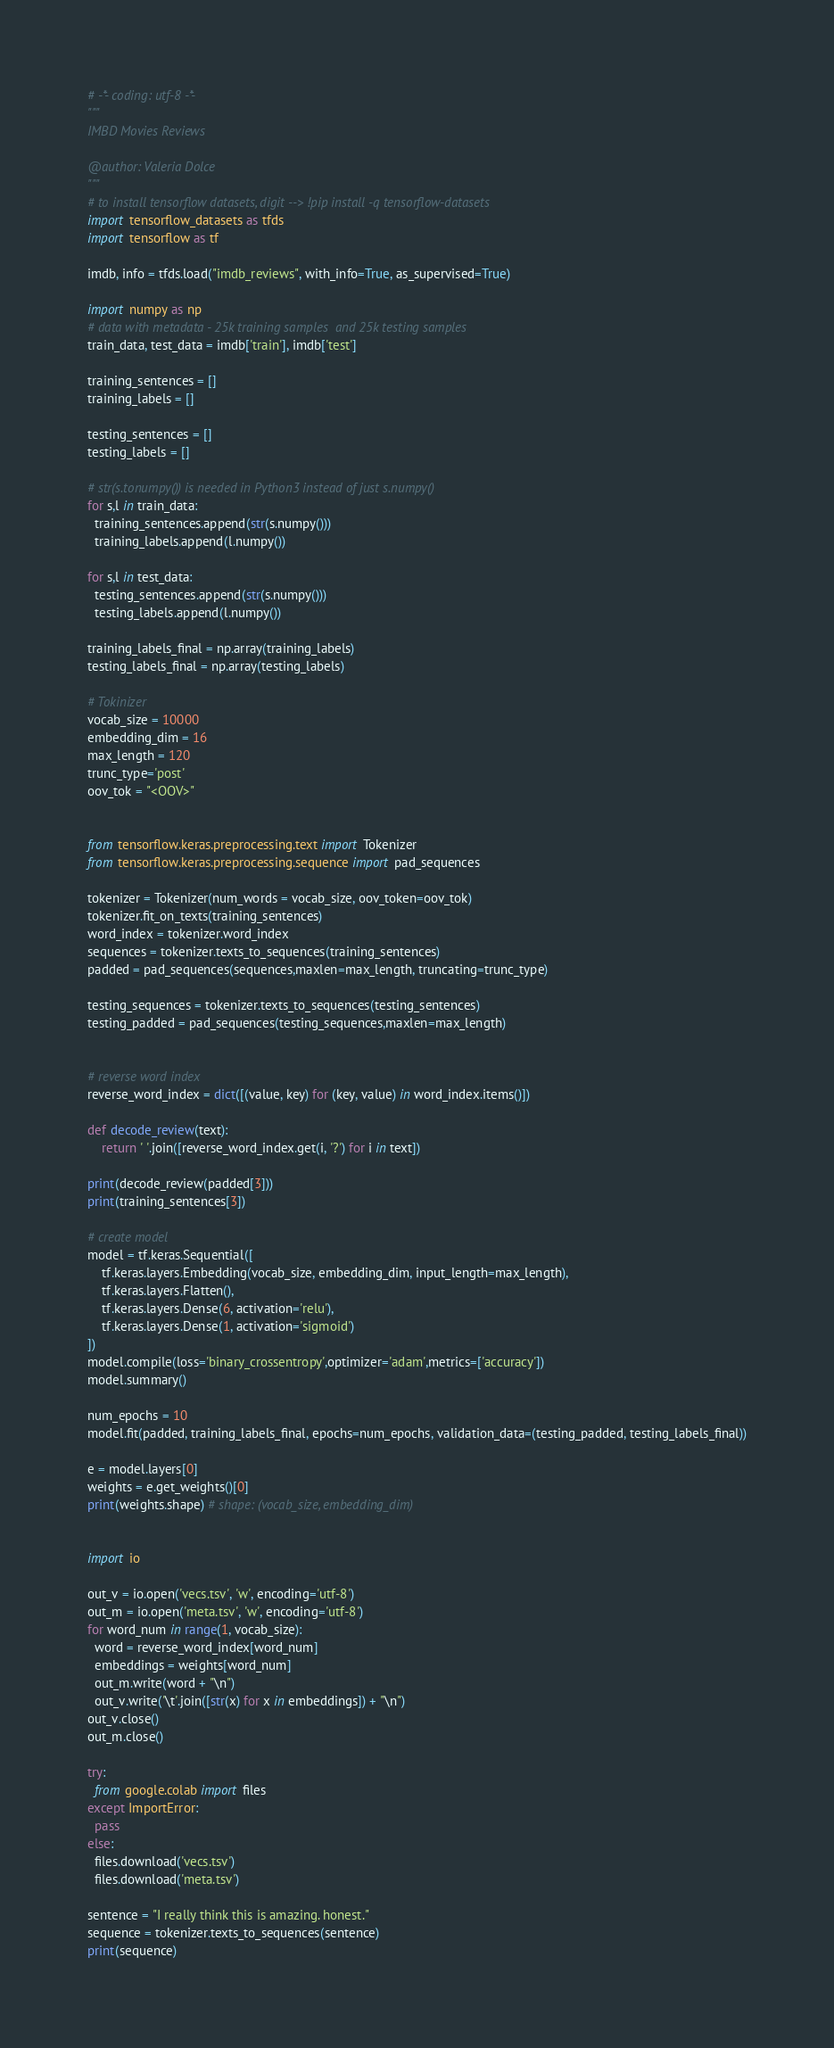Convert code to text. <code><loc_0><loc_0><loc_500><loc_500><_Python_># -*- coding: utf-8 -*-
"""
IMBD Movies Reviews 

@author: Valeria Dolce
"""
# to install tensorflow datasets, digit --> !pip install -q tensorflow-datasets
import tensorflow_datasets as tfds
import tensorflow as tf

imdb, info = tfds.load("imdb_reviews", with_info=True, as_supervised=True)

import numpy as np
# data with metadata - 25k training samples  and 25k testing samples
train_data, test_data = imdb['train'], imdb['test']

training_sentences = []
training_labels = []

testing_sentences = []
testing_labels = []

# str(s.tonumpy()) is needed in Python3 instead of just s.numpy()
for s,l in train_data:
  training_sentences.append(str(s.numpy()))
  training_labels.append(l.numpy())
  
for s,l in test_data:
  testing_sentences.append(str(s.numpy()))
  testing_labels.append(l.numpy())
  
training_labels_final = np.array(training_labels)
testing_labels_final = np.array(testing_labels)

# Tokinizer
vocab_size = 10000
embedding_dim = 16
max_length = 120
trunc_type='post'
oov_tok = "<OOV>"


from tensorflow.keras.preprocessing.text import Tokenizer
from tensorflow.keras.preprocessing.sequence import pad_sequences

tokenizer = Tokenizer(num_words = vocab_size, oov_token=oov_tok)
tokenizer.fit_on_texts(training_sentences)
word_index = tokenizer.word_index
sequences = tokenizer.texts_to_sequences(training_sentences)
padded = pad_sequences(sequences,maxlen=max_length, truncating=trunc_type)

testing_sequences = tokenizer.texts_to_sequences(testing_sentences)
testing_padded = pad_sequences(testing_sequences,maxlen=max_length)


# reverse word index
reverse_word_index = dict([(value, key) for (key, value) in word_index.items()])

def decode_review(text):
    return ' '.join([reverse_word_index.get(i, '?') for i in text])

print(decode_review(padded[3]))
print(training_sentences[3])

# create model 
model = tf.keras.Sequential([
    tf.keras.layers.Embedding(vocab_size, embedding_dim, input_length=max_length),
    tf.keras.layers.Flatten(),
    tf.keras.layers.Dense(6, activation='relu'),
    tf.keras.layers.Dense(1, activation='sigmoid')
])
model.compile(loss='binary_crossentropy',optimizer='adam',metrics=['accuracy'])
model.summary()

num_epochs = 10
model.fit(padded, training_labels_final, epochs=num_epochs, validation_data=(testing_padded, testing_labels_final))

e = model.layers[0]
weights = e.get_weights()[0]
print(weights.shape) # shape: (vocab_size, embedding_dim)


import io

out_v = io.open('vecs.tsv', 'w', encoding='utf-8')
out_m = io.open('meta.tsv', 'w', encoding='utf-8')
for word_num in range(1, vocab_size):
  word = reverse_word_index[word_num]
  embeddings = weights[word_num]
  out_m.write(word + "\n")
  out_v.write('\t'.join([str(x) for x in embeddings]) + "\n")
out_v.close()
out_m.close()

try:
  from google.colab import files
except ImportError:
  pass
else:
  files.download('vecs.tsv')
  files.download('meta.tsv')
  
sentence = "I really think this is amazing. honest."
sequence = tokenizer.texts_to_sequences(sentence)
print(sequence)</code> 